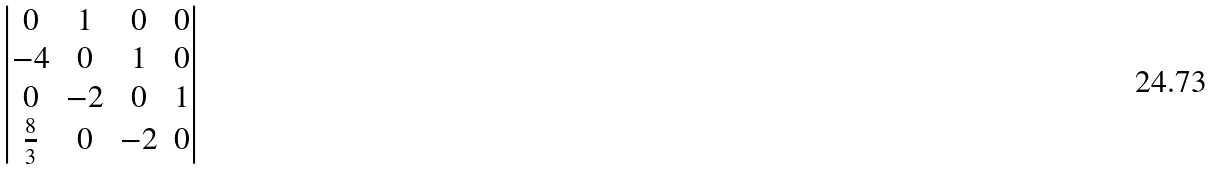<formula> <loc_0><loc_0><loc_500><loc_500>\begin{vmatrix} 0 & 1 & 0 & 0 \\ - 4 & 0 & 1 & 0 \\ 0 & - 2 & 0 & 1 \\ \frac { 8 } { 3 } & 0 & - 2 & 0 \end{vmatrix}</formula> 